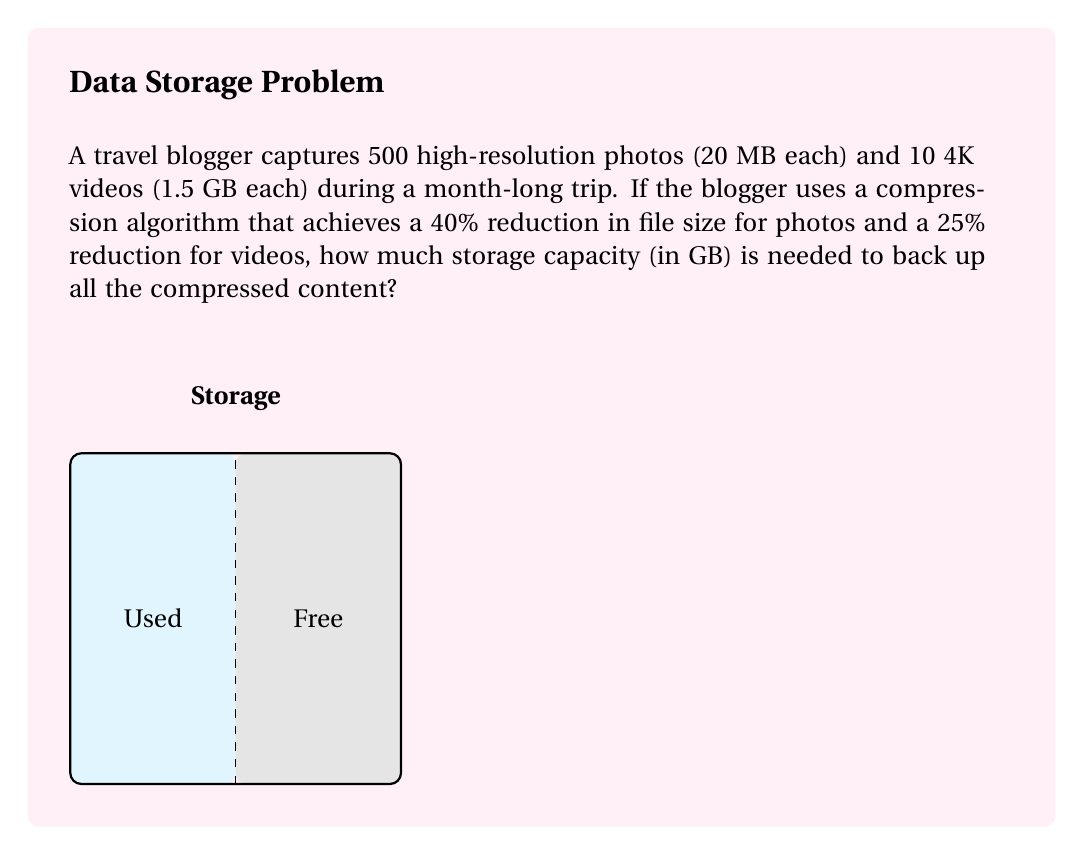Teach me how to tackle this problem. Let's break this down step-by-step:

1. Calculate the original size of photos:
   $500 \times 20 \text{ MB} = 10,000 \text{ MB} = 10 \text{ GB}$

2. Calculate the original size of videos:
   $10 \times 1.5 \text{ GB} = 15 \text{ GB}$

3. Total original size:
   $10 \text{ GB} + 15 \text{ GB} = 25 \text{ GB}$

4. Apply compression to photos:
   $10 \text{ GB} \times (1 - 0.40) = 6 \text{ GB}$

5. Apply compression to videos:
   $15 \text{ GB} \times (1 - 0.25) = 11.25 \text{ GB}$

6. Sum up the compressed sizes:
   $6 \text{ GB} + 11.25 \text{ GB} = 17.25 \text{ GB}$

Therefore, the storage capacity needed for the compressed content is 17.25 GB.
Answer: 17.25 GB 